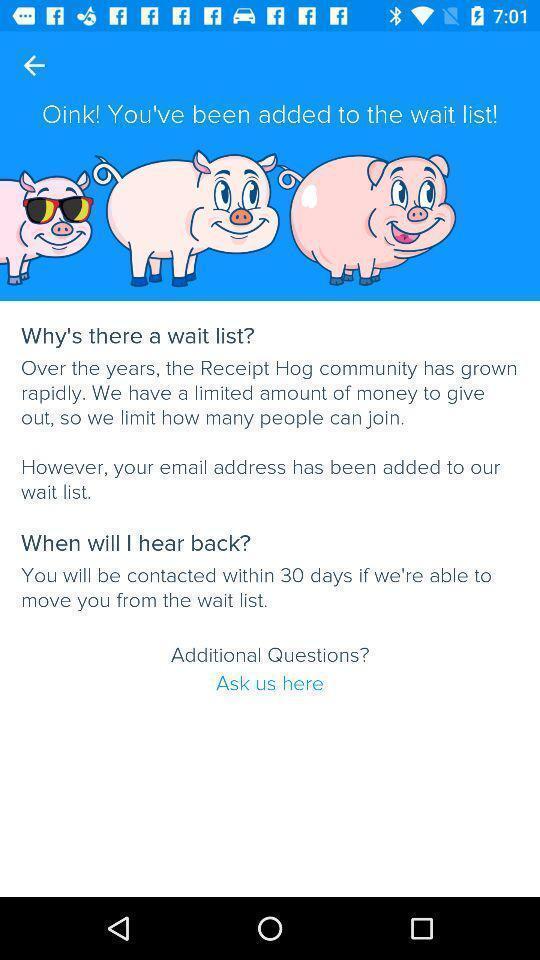Tell me what you see in this picture. Screen displaying the questions in learning app. 